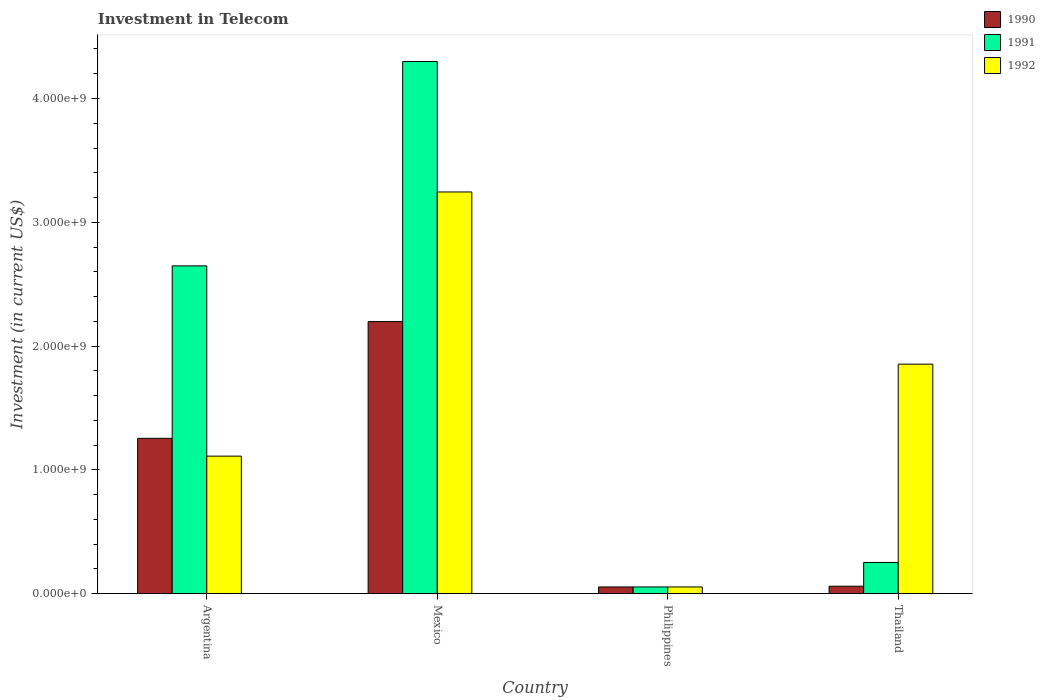How many different coloured bars are there?
Provide a short and direct response. 3. Are the number of bars per tick equal to the number of legend labels?
Make the answer very short. Yes. In how many cases, is the number of bars for a given country not equal to the number of legend labels?
Keep it short and to the point. 0. What is the amount invested in telecom in 1991 in Mexico?
Provide a succinct answer. 4.30e+09. Across all countries, what is the maximum amount invested in telecom in 1992?
Your response must be concise. 3.24e+09. Across all countries, what is the minimum amount invested in telecom in 1990?
Keep it short and to the point. 5.42e+07. In which country was the amount invested in telecom in 1990 maximum?
Make the answer very short. Mexico. What is the total amount invested in telecom in 1990 in the graph?
Your answer should be very brief. 3.57e+09. What is the difference between the amount invested in telecom in 1991 in Argentina and that in Philippines?
Provide a succinct answer. 2.59e+09. What is the difference between the amount invested in telecom in 1991 in Mexico and the amount invested in telecom in 1992 in Argentina?
Give a very brief answer. 3.19e+09. What is the average amount invested in telecom in 1991 per country?
Give a very brief answer. 1.81e+09. What is the difference between the amount invested in telecom of/in 1990 and amount invested in telecom of/in 1991 in Thailand?
Keep it short and to the point. -1.92e+08. In how many countries, is the amount invested in telecom in 1992 greater than 2800000000 US$?
Give a very brief answer. 1. What is the ratio of the amount invested in telecom in 1990 in Argentina to that in Philippines?
Ensure brevity in your answer.  23.15. Is the amount invested in telecom in 1992 in Argentina less than that in Philippines?
Give a very brief answer. No. Is the difference between the amount invested in telecom in 1990 in Mexico and Philippines greater than the difference between the amount invested in telecom in 1991 in Mexico and Philippines?
Your answer should be very brief. No. What is the difference between the highest and the second highest amount invested in telecom in 1991?
Provide a succinct answer. 1.65e+09. What is the difference between the highest and the lowest amount invested in telecom in 1990?
Keep it short and to the point. 2.14e+09. In how many countries, is the amount invested in telecom in 1990 greater than the average amount invested in telecom in 1990 taken over all countries?
Keep it short and to the point. 2. Is the sum of the amount invested in telecom in 1991 in Mexico and Thailand greater than the maximum amount invested in telecom in 1990 across all countries?
Make the answer very short. Yes. What does the 2nd bar from the left in Thailand represents?
Your answer should be compact. 1991. How many bars are there?
Your response must be concise. 12. Are all the bars in the graph horizontal?
Provide a succinct answer. No. What is the difference between two consecutive major ticks on the Y-axis?
Provide a short and direct response. 1.00e+09. Are the values on the major ticks of Y-axis written in scientific E-notation?
Offer a very short reply. Yes. How many legend labels are there?
Give a very brief answer. 3. How are the legend labels stacked?
Keep it short and to the point. Vertical. What is the title of the graph?
Your answer should be compact. Investment in Telecom. Does "1972" appear as one of the legend labels in the graph?
Your answer should be very brief. No. What is the label or title of the X-axis?
Ensure brevity in your answer.  Country. What is the label or title of the Y-axis?
Provide a succinct answer. Investment (in current US$). What is the Investment (in current US$) of 1990 in Argentina?
Offer a very short reply. 1.25e+09. What is the Investment (in current US$) of 1991 in Argentina?
Give a very brief answer. 2.65e+09. What is the Investment (in current US$) in 1992 in Argentina?
Make the answer very short. 1.11e+09. What is the Investment (in current US$) in 1990 in Mexico?
Ensure brevity in your answer.  2.20e+09. What is the Investment (in current US$) in 1991 in Mexico?
Offer a very short reply. 4.30e+09. What is the Investment (in current US$) of 1992 in Mexico?
Your answer should be very brief. 3.24e+09. What is the Investment (in current US$) in 1990 in Philippines?
Provide a succinct answer. 5.42e+07. What is the Investment (in current US$) in 1991 in Philippines?
Keep it short and to the point. 5.42e+07. What is the Investment (in current US$) of 1992 in Philippines?
Your answer should be compact. 5.42e+07. What is the Investment (in current US$) in 1990 in Thailand?
Your answer should be compact. 6.00e+07. What is the Investment (in current US$) of 1991 in Thailand?
Offer a terse response. 2.52e+08. What is the Investment (in current US$) of 1992 in Thailand?
Your answer should be compact. 1.85e+09. Across all countries, what is the maximum Investment (in current US$) of 1990?
Make the answer very short. 2.20e+09. Across all countries, what is the maximum Investment (in current US$) in 1991?
Offer a very short reply. 4.30e+09. Across all countries, what is the maximum Investment (in current US$) in 1992?
Your response must be concise. 3.24e+09. Across all countries, what is the minimum Investment (in current US$) of 1990?
Keep it short and to the point. 5.42e+07. Across all countries, what is the minimum Investment (in current US$) in 1991?
Your answer should be compact. 5.42e+07. Across all countries, what is the minimum Investment (in current US$) of 1992?
Make the answer very short. 5.42e+07. What is the total Investment (in current US$) in 1990 in the graph?
Make the answer very short. 3.57e+09. What is the total Investment (in current US$) of 1991 in the graph?
Make the answer very short. 7.25e+09. What is the total Investment (in current US$) of 1992 in the graph?
Offer a terse response. 6.26e+09. What is the difference between the Investment (in current US$) of 1990 in Argentina and that in Mexico?
Your response must be concise. -9.43e+08. What is the difference between the Investment (in current US$) in 1991 in Argentina and that in Mexico?
Offer a terse response. -1.65e+09. What is the difference between the Investment (in current US$) of 1992 in Argentina and that in Mexico?
Offer a very short reply. -2.13e+09. What is the difference between the Investment (in current US$) of 1990 in Argentina and that in Philippines?
Offer a very short reply. 1.20e+09. What is the difference between the Investment (in current US$) of 1991 in Argentina and that in Philippines?
Give a very brief answer. 2.59e+09. What is the difference between the Investment (in current US$) of 1992 in Argentina and that in Philippines?
Offer a terse response. 1.06e+09. What is the difference between the Investment (in current US$) in 1990 in Argentina and that in Thailand?
Offer a very short reply. 1.19e+09. What is the difference between the Investment (in current US$) of 1991 in Argentina and that in Thailand?
Your answer should be compact. 2.40e+09. What is the difference between the Investment (in current US$) in 1992 in Argentina and that in Thailand?
Provide a short and direct response. -7.43e+08. What is the difference between the Investment (in current US$) in 1990 in Mexico and that in Philippines?
Your response must be concise. 2.14e+09. What is the difference between the Investment (in current US$) of 1991 in Mexico and that in Philippines?
Your answer should be compact. 4.24e+09. What is the difference between the Investment (in current US$) of 1992 in Mexico and that in Philippines?
Make the answer very short. 3.19e+09. What is the difference between the Investment (in current US$) of 1990 in Mexico and that in Thailand?
Offer a terse response. 2.14e+09. What is the difference between the Investment (in current US$) in 1991 in Mexico and that in Thailand?
Give a very brief answer. 4.05e+09. What is the difference between the Investment (in current US$) of 1992 in Mexico and that in Thailand?
Your response must be concise. 1.39e+09. What is the difference between the Investment (in current US$) of 1990 in Philippines and that in Thailand?
Offer a terse response. -5.80e+06. What is the difference between the Investment (in current US$) of 1991 in Philippines and that in Thailand?
Ensure brevity in your answer.  -1.98e+08. What is the difference between the Investment (in current US$) of 1992 in Philippines and that in Thailand?
Offer a terse response. -1.80e+09. What is the difference between the Investment (in current US$) of 1990 in Argentina and the Investment (in current US$) of 1991 in Mexico?
Ensure brevity in your answer.  -3.04e+09. What is the difference between the Investment (in current US$) in 1990 in Argentina and the Investment (in current US$) in 1992 in Mexico?
Offer a very short reply. -1.99e+09. What is the difference between the Investment (in current US$) of 1991 in Argentina and the Investment (in current US$) of 1992 in Mexico?
Provide a short and direct response. -5.97e+08. What is the difference between the Investment (in current US$) in 1990 in Argentina and the Investment (in current US$) in 1991 in Philippines?
Your answer should be compact. 1.20e+09. What is the difference between the Investment (in current US$) in 1990 in Argentina and the Investment (in current US$) in 1992 in Philippines?
Keep it short and to the point. 1.20e+09. What is the difference between the Investment (in current US$) in 1991 in Argentina and the Investment (in current US$) in 1992 in Philippines?
Offer a terse response. 2.59e+09. What is the difference between the Investment (in current US$) in 1990 in Argentina and the Investment (in current US$) in 1991 in Thailand?
Provide a succinct answer. 1.00e+09. What is the difference between the Investment (in current US$) of 1990 in Argentina and the Investment (in current US$) of 1992 in Thailand?
Your answer should be compact. -5.99e+08. What is the difference between the Investment (in current US$) of 1991 in Argentina and the Investment (in current US$) of 1992 in Thailand?
Provide a short and direct response. 7.94e+08. What is the difference between the Investment (in current US$) of 1990 in Mexico and the Investment (in current US$) of 1991 in Philippines?
Your answer should be compact. 2.14e+09. What is the difference between the Investment (in current US$) of 1990 in Mexico and the Investment (in current US$) of 1992 in Philippines?
Provide a short and direct response. 2.14e+09. What is the difference between the Investment (in current US$) of 1991 in Mexico and the Investment (in current US$) of 1992 in Philippines?
Your answer should be compact. 4.24e+09. What is the difference between the Investment (in current US$) of 1990 in Mexico and the Investment (in current US$) of 1991 in Thailand?
Make the answer very short. 1.95e+09. What is the difference between the Investment (in current US$) in 1990 in Mexico and the Investment (in current US$) in 1992 in Thailand?
Your response must be concise. 3.44e+08. What is the difference between the Investment (in current US$) in 1991 in Mexico and the Investment (in current US$) in 1992 in Thailand?
Provide a short and direct response. 2.44e+09. What is the difference between the Investment (in current US$) of 1990 in Philippines and the Investment (in current US$) of 1991 in Thailand?
Keep it short and to the point. -1.98e+08. What is the difference between the Investment (in current US$) of 1990 in Philippines and the Investment (in current US$) of 1992 in Thailand?
Your response must be concise. -1.80e+09. What is the difference between the Investment (in current US$) of 1991 in Philippines and the Investment (in current US$) of 1992 in Thailand?
Provide a succinct answer. -1.80e+09. What is the average Investment (in current US$) in 1990 per country?
Provide a succinct answer. 8.92e+08. What is the average Investment (in current US$) in 1991 per country?
Provide a short and direct response. 1.81e+09. What is the average Investment (in current US$) in 1992 per country?
Offer a terse response. 1.57e+09. What is the difference between the Investment (in current US$) in 1990 and Investment (in current US$) in 1991 in Argentina?
Your answer should be very brief. -1.39e+09. What is the difference between the Investment (in current US$) in 1990 and Investment (in current US$) in 1992 in Argentina?
Give a very brief answer. 1.44e+08. What is the difference between the Investment (in current US$) in 1991 and Investment (in current US$) in 1992 in Argentina?
Make the answer very short. 1.54e+09. What is the difference between the Investment (in current US$) in 1990 and Investment (in current US$) in 1991 in Mexico?
Your answer should be very brief. -2.10e+09. What is the difference between the Investment (in current US$) in 1990 and Investment (in current US$) in 1992 in Mexico?
Give a very brief answer. -1.05e+09. What is the difference between the Investment (in current US$) in 1991 and Investment (in current US$) in 1992 in Mexico?
Provide a short and direct response. 1.05e+09. What is the difference between the Investment (in current US$) of 1990 and Investment (in current US$) of 1991 in Thailand?
Make the answer very short. -1.92e+08. What is the difference between the Investment (in current US$) of 1990 and Investment (in current US$) of 1992 in Thailand?
Make the answer very short. -1.79e+09. What is the difference between the Investment (in current US$) in 1991 and Investment (in current US$) in 1992 in Thailand?
Give a very brief answer. -1.60e+09. What is the ratio of the Investment (in current US$) of 1990 in Argentina to that in Mexico?
Offer a very short reply. 0.57. What is the ratio of the Investment (in current US$) in 1991 in Argentina to that in Mexico?
Ensure brevity in your answer.  0.62. What is the ratio of the Investment (in current US$) of 1992 in Argentina to that in Mexico?
Provide a succinct answer. 0.34. What is the ratio of the Investment (in current US$) in 1990 in Argentina to that in Philippines?
Ensure brevity in your answer.  23.15. What is the ratio of the Investment (in current US$) in 1991 in Argentina to that in Philippines?
Provide a succinct answer. 48.86. What is the ratio of the Investment (in current US$) of 1992 in Argentina to that in Philippines?
Ensure brevity in your answer.  20.5. What is the ratio of the Investment (in current US$) of 1990 in Argentina to that in Thailand?
Make the answer very short. 20.91. What is the ratio of the Investment (in current US$) of 1991 in Argentina to that in Thailand?
Your answer should be compact. 10.51. What is the ratio of the Investment (in current US$) in 1992 in Argentina to that in Thailand?
Offer a terse response. 0.6. What is the ratio of the Investment (in current US$) in 1990 in Mexico to that in Philippines?
Offer a very short reply. 40.55. What is the ratio of the Investment (in current US$) of 1991 in Mexico to that in Philippines?
Ensure brevity in your answer.  79.32. What is the ratio of the Investment (in current US$) of 1992 in Mexico to that in Philippines?
Give a very brief answer. 59.87. What is the ratio of the Investment (in current US$) of 1990 in Mexico to that in Thailand?
Your response must be concise. 36.63. What is the ratio of the Investment (in current US$) in 1991 in Mexico to that in Thailand?
Keep it short and to the point. 17.06. What is the ratio of the Investment (in current US$) in 1992 in Mexico to that in Thailand?
Your answer should be compact. 1.75. What is the ratio of the Investment (in current US$) of 1990 in Philippines to that in Thailand?
Make the answer very short. 0.9. What is the ratio of the Investment (in current US$) of 1991 in Philippines to that in Thailand?
Offer a terse response. 0.22. What is the ratio of the Investment (in current US$) of 1992 in Philippines to that in Thailand?
Your answer should be very brief. 0.03. What is the difference between the highest and the second highest Investment (in current US$) of 1990?
Your answer should be compact. 9.43e+08. What is the difference between the highest and the second highest Investment (in current US$) in 1991?
Keep it short and to the point. 1.65e+09. What is the difference between the highest and the second highest Investment (in current US$) of 1992?
Offer a terse response. 1.39e+09. What is the difference between the highest and the lowest Investment (in current US$) of 1990?
Ensure brevity in your answer.  2.14e+09. What is the difference between the highest and the lowest Investment (in current US$) in 1991?
Provide a short and direct response. 4.24e+09. What is the difference between the highest and the lowest Investment (in current US$) of 1992?
Keep it short and to the point. 3.19e+09. 